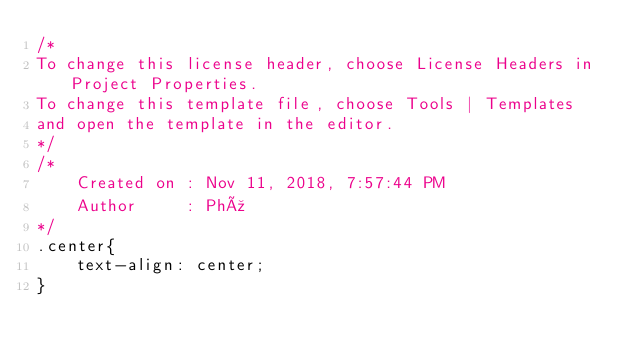<code> <loc_0><loc_0><loc_500><loc_500><_CSS_>/*
To change this license header, choose License Headers in Project Properties.
To change this template file, choose Tools | Templates
and open the template in the editor.
*/
/* 
    Created on : Nov 11, 2018, 7:57:44 PM
    Author     : Phú
*/
.center{
    text-align: center;
}</code> 